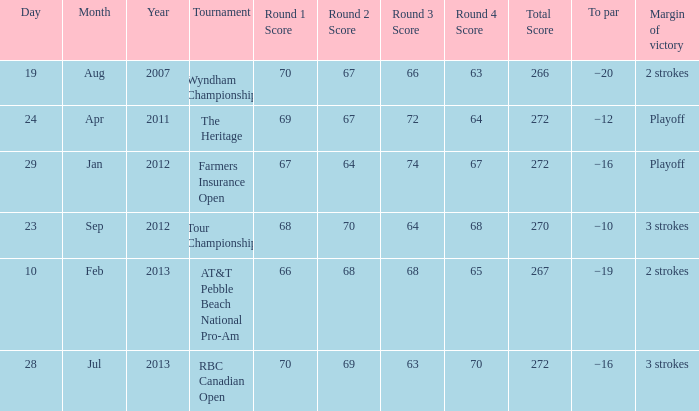What is the to par of the match with a winning score 69-67-72-64=272? −12. 